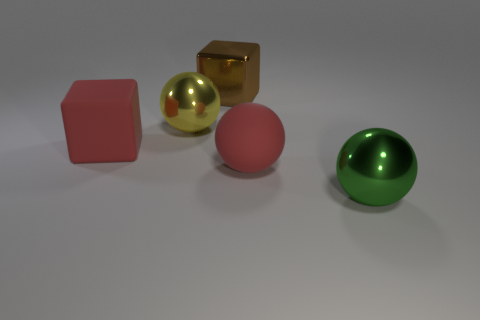There is a big matte object behind the big rubber sphere; does it have the same color as the rubber sphere?
Your answer should be compact. Yes. What number of other objects are the same color as the metal cube?
Give a very brief answer. 0. How many objects are either brown cubes or tiny matte spheres?
Make the answer very short. 1. What number of things are either large brown shiny cubes or big objects on the right side of the yellow shiny object?
Make the answer very short. 3. Is the material of the brown cube the same as the yellow ball?
Provide a short and direct response. Yes. What number of other things are there of the same material as the brown object
Make the answer very short. 2. Are there more tiny red balls than red matte balls?
Offer a very short reply. No. Do the red object behind the big red sphere and the large brown metal thing have the same shape?
Your response must be concise. Yes. Is the number of large metallic objects less than the number of things?
Offer a very short reply. Yes. What material is the brown cube that is the same size as the green shiny thing?
Provide a short and direct response. Metal. 